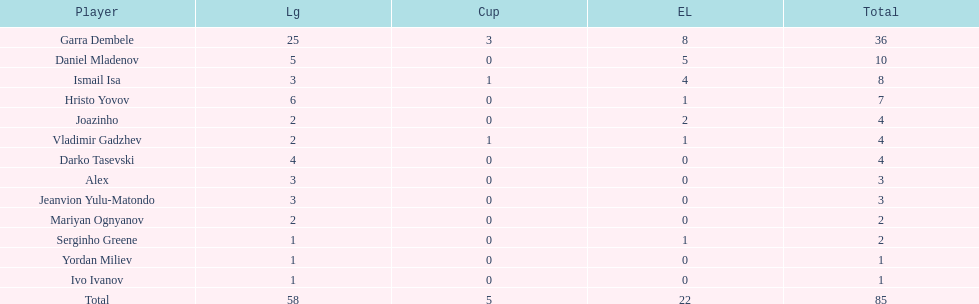What is the sum of the cup total and the europa league total? 27. 